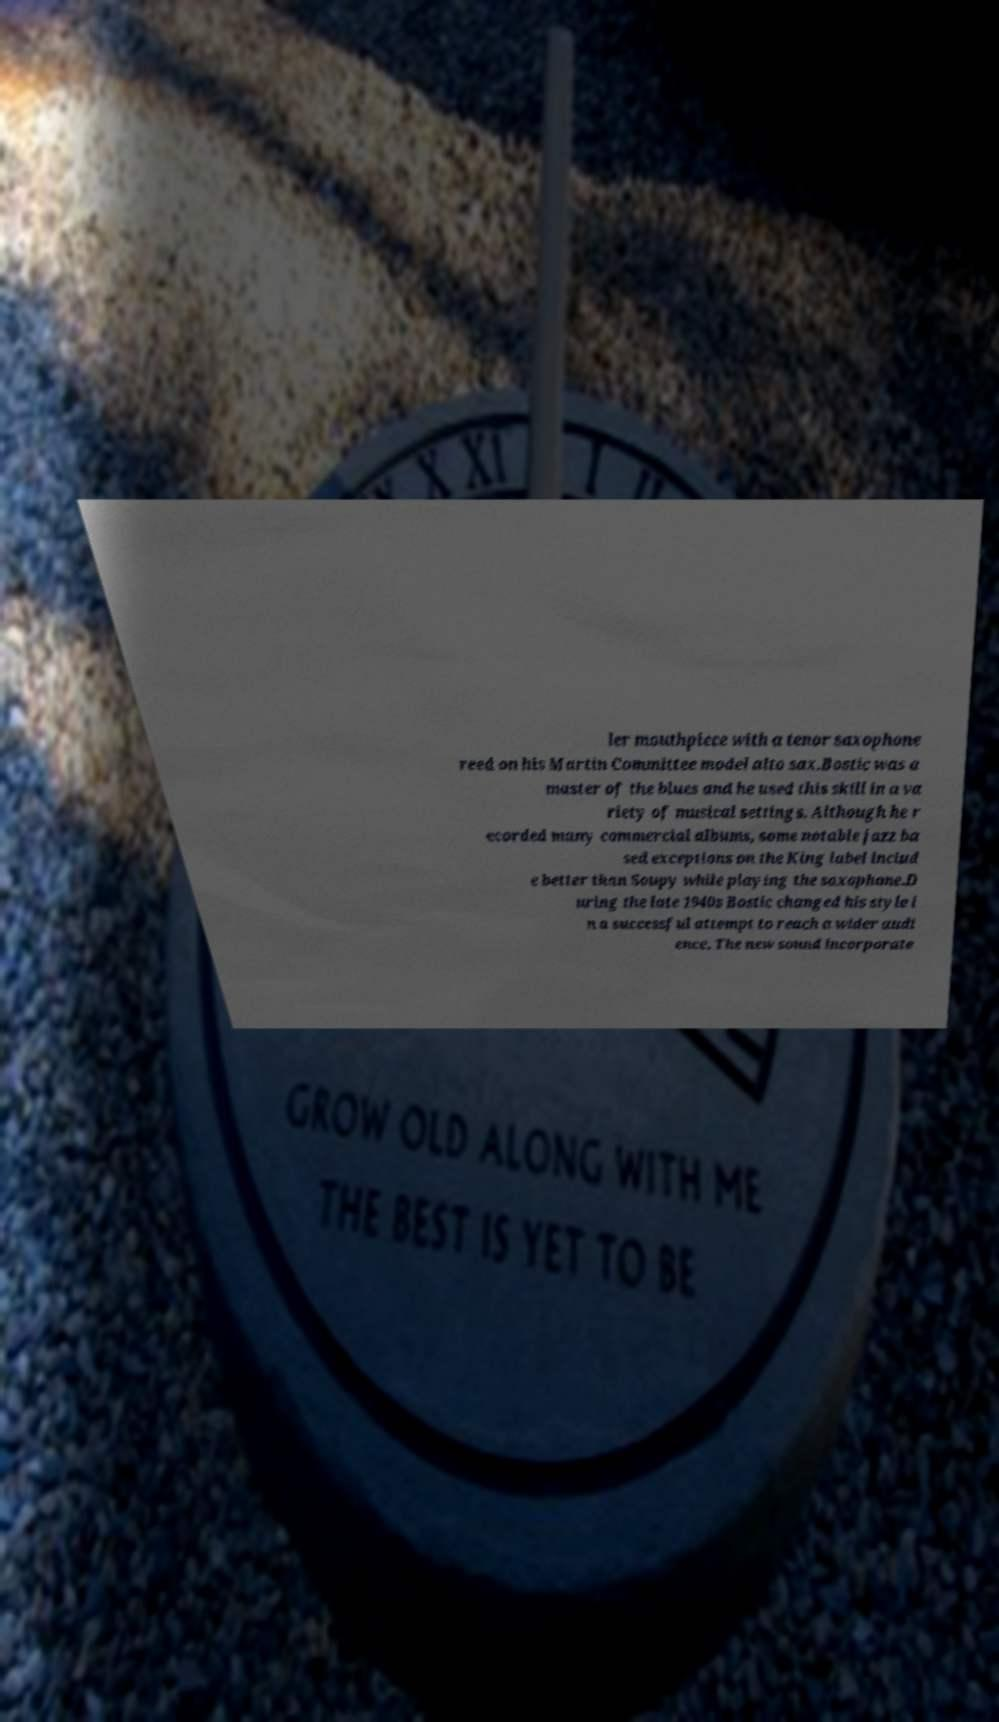What messages or text are displayed in this image? I need them in a readable, typed format. ler mouthpiece with a tenor saxophone reed on his Martin Committee model alto sax.Bostic was a master of the blues and he used this skill in a va riety of musical settings. Although he r ecorded many commercial albums, some notable jazz ba sed exceptions on the King label includ e better than Soupy while playing the saxophone.D uring the late 1940s Bostic changed his style i n a successful attempt to reach a wider audi ence. The new sound incorporate 